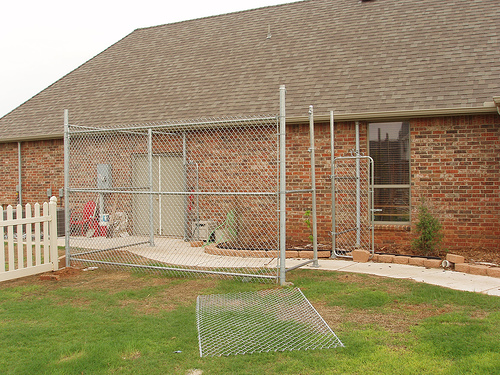<image>
Is there a sky behind the building? Yes. From this viewpoint, the sky is positioned behind the building, with the building partially or fully occluding the sky. 